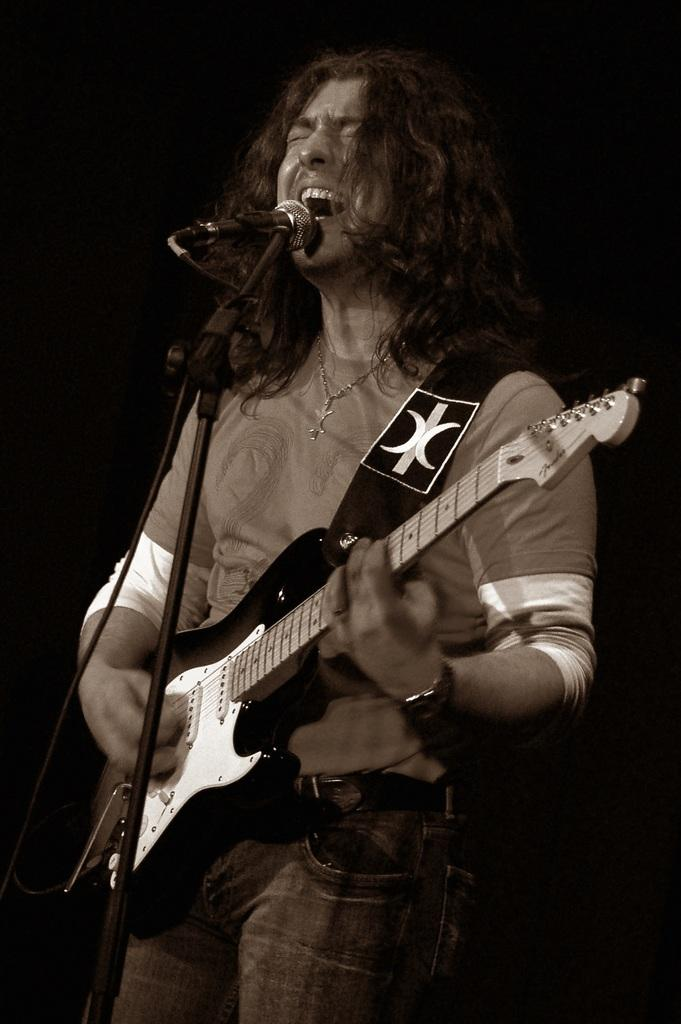What is the man in the image doing? The man is singing in the image. What is the man using to amplify his voice? The man is using a microphone in the image. What musical instrument is the man playing? The man is playing a guitar in the image. How does the man increase the temperature in the image? The image does not show the man increasing the temperature; there is no indication of any heat source or change in temperature. 